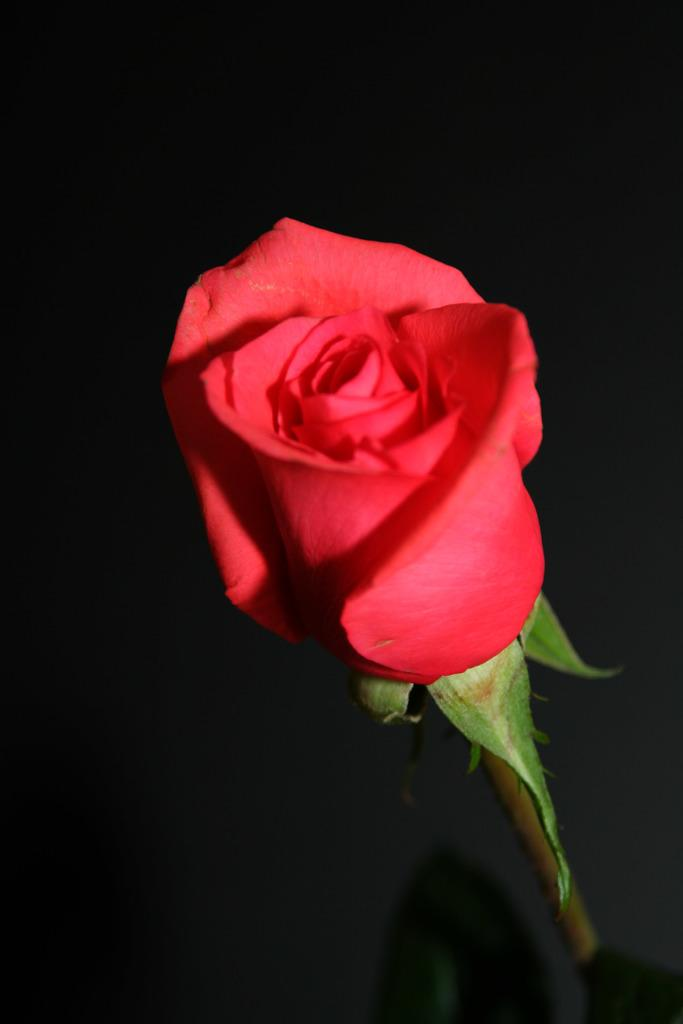What type of flower is in the image? There is a rose in the image. What color is the rose? The rose is red in color. Can you describe any part of the rose besides the petals? The image shows the stem of the rose. Is there a beggar asking for money near the rose in the image? There is no beggar present in the image; it only shows a red rose with its stem. 